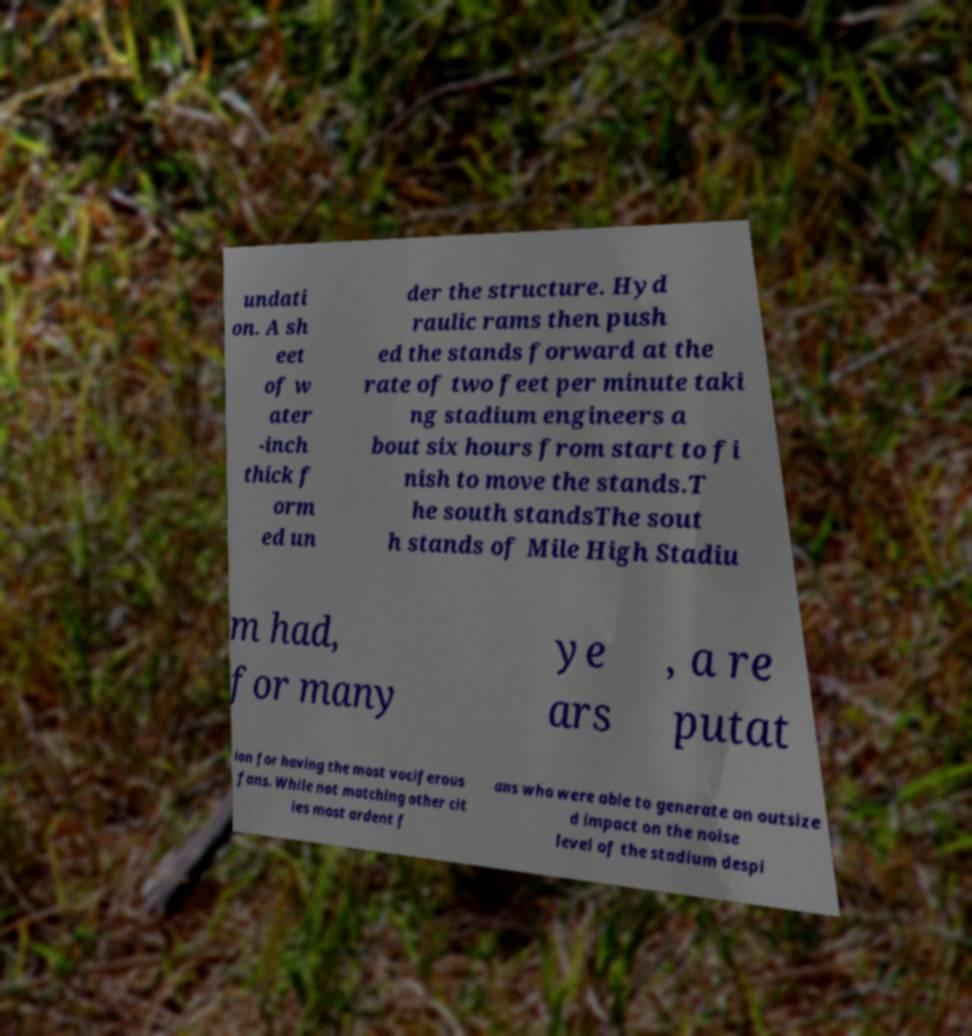Could you extract and type out the text from this image? undati on. A sh eet of w ater -inch thick f orm ed un der the structure. Hyd raulic rams then push ed the stands forward at the rate of two feet per minute taki ng stadium engineers a bout six hours from start to fi nish to move the stands.T he south standsThe sout h stands of Mile High Stadiu m had, for many ye ars , a re putat ion for having the most vociferous fans. While not matching other cit ies most ardent f ans who were able to generate an outsize d impact on the noise level of the stadium despi 